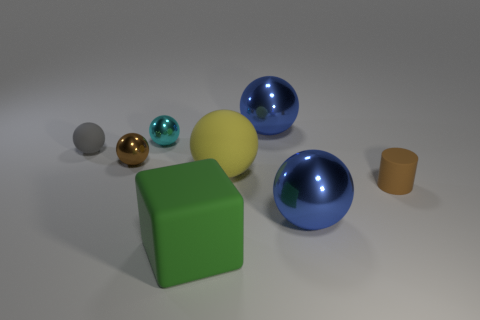Does the cyan object have the same size as the gray rubber thing?
Your answer should be very brief. Yes. Do the big metal sphere behind the gray sphere and the big rubber ball have the same color?
Your response must be concise. No. There is a small rubber ball; how many big green rubber cubes are on the left side of it?
Offer a terse response. 0. Are there more large metallic things than small cylinders?
Your answer should be compact. Yes. What shape is the tiny object that is right of the tiny gray ball and behind the small brown metallic ball?
Your answer should be compact. Sphere. Is there a large blue ball?
Your answer should be very brief. Yes. What material is the yellow thing that is the same shape as the small cyan object?
Your answer should be compact. Rubber. The small rubber thing to the right of the big matte thing on the left side of the large yellow rubber sphere in front of the small rubber ball is what shape?
Your answer should be compact. Cylinder. How many large blue objects have the same shape as the tiny cyan thing?
Give a very brief answer. 2. Does the small thing that is to the right of the yellow sphere have the same color as the small shiny sphere that is in front of the tiny cyan metallic thing?
Provide a succinct answer. Yes. 